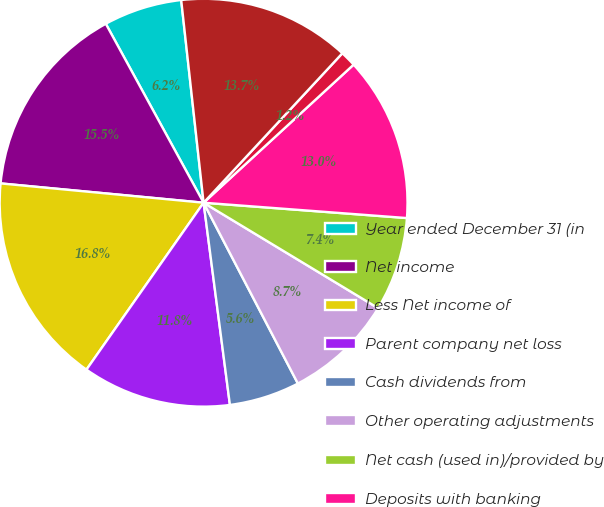Convert chart. <chart><loc_0><loc_0><loc_500><loc_500><pie_chart><fcel>Year ended December 31 (in<fcel>Net income<fcel>Less Net income of<fcel>Parent company net loss<fcel>Cash dividends from<fcel>Other operating adjustments<fcel>Net cash (used in)/provided by<fcel>Deposits with banking<fcel>Proceeds from paydowns and<fcel>Purchases<nl><fcel>6.21%<fcel>15.53%<fcel>16.77%<fcel>11.8%<fcel>5.59%<fcel>8.7%<fcel>7.45%<fcel>13.04%<fcel>1.25%<fcel>13.66%<nl></chart> 